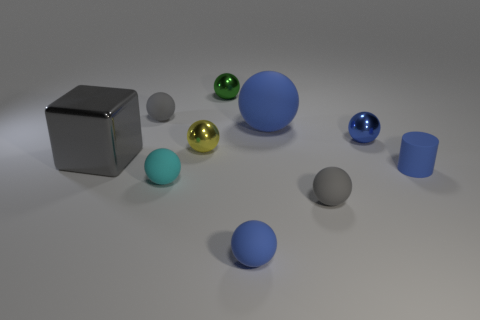Is the color of the rubber cylinder the same as the big matte thing?
Offer a terse response. Yes. There is a big ball behind the yellow metallic object; what material is it?
Provide a short and direct response. Rubber. Is there a blue shiny thing of the same shape as the cyan rubber thing?
Your response must be concise. Yes. How many green objects are the same shape as the big blue matte object?
Your answer should be very brief. 1. There is a gray object that is in front of the matte cylinder; does it have the same size as the gray matte sphere that is left of the small yellow metallic sphere?
Offer a very short reply. Yes. There is a big blue matte thing that is behind the small metallic sphere right of the small blue rubber sphere; what is its shape?
Your answer should be compact. Sphere. Are there an equal number of things in front of the small blue shiny sphere and matte things?
Offer a terse response. Yes. The small blue ball in front of the gray rubber object that is to the right of the small gray object behind the tiny cylinder is made of what material?
Ensure brevity in your answer.  Rubber. Is there a blue cylinder that has the same size as the blue shiny ball?
Keep it short and to the point. Yes. The small yellow thing is what shape?
Keep it short and to the point. Sphere. 